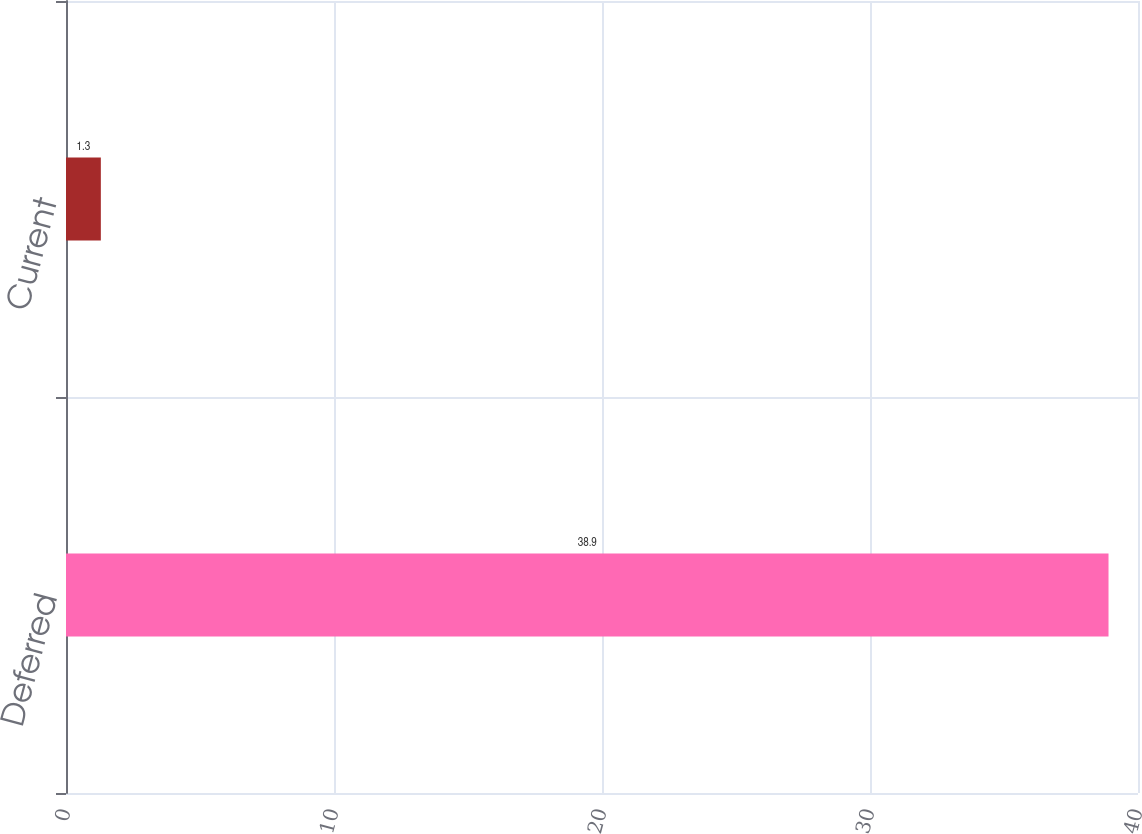<chart> <loc_0><loc_0><loc_500><loc_500><bar_chart><fcel>Deferred<fcel>Current<nl><fcel>38.9<fcel>1.3<nl></chart> 